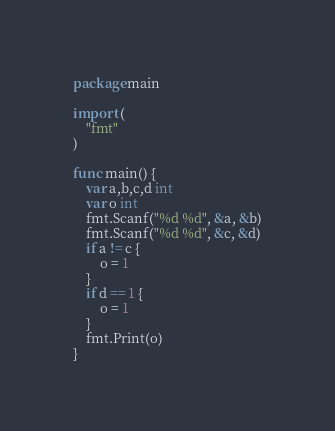Convert code to text. <code><loc_0><loc_0><loc_500><loc_500><_Go_>package main
 
import (
	"fmt"
)

func main() {
	var a,b,c,d int
	var o int
	fmt.Scanf("%d %d", &a, &b)
	fmt.Scanf("%d %d", &c, &d)
	if a != c {
		o = 1
	}
	if d == 1 {
		o = 1
	}
	fmt.Print(o)
}</code> 